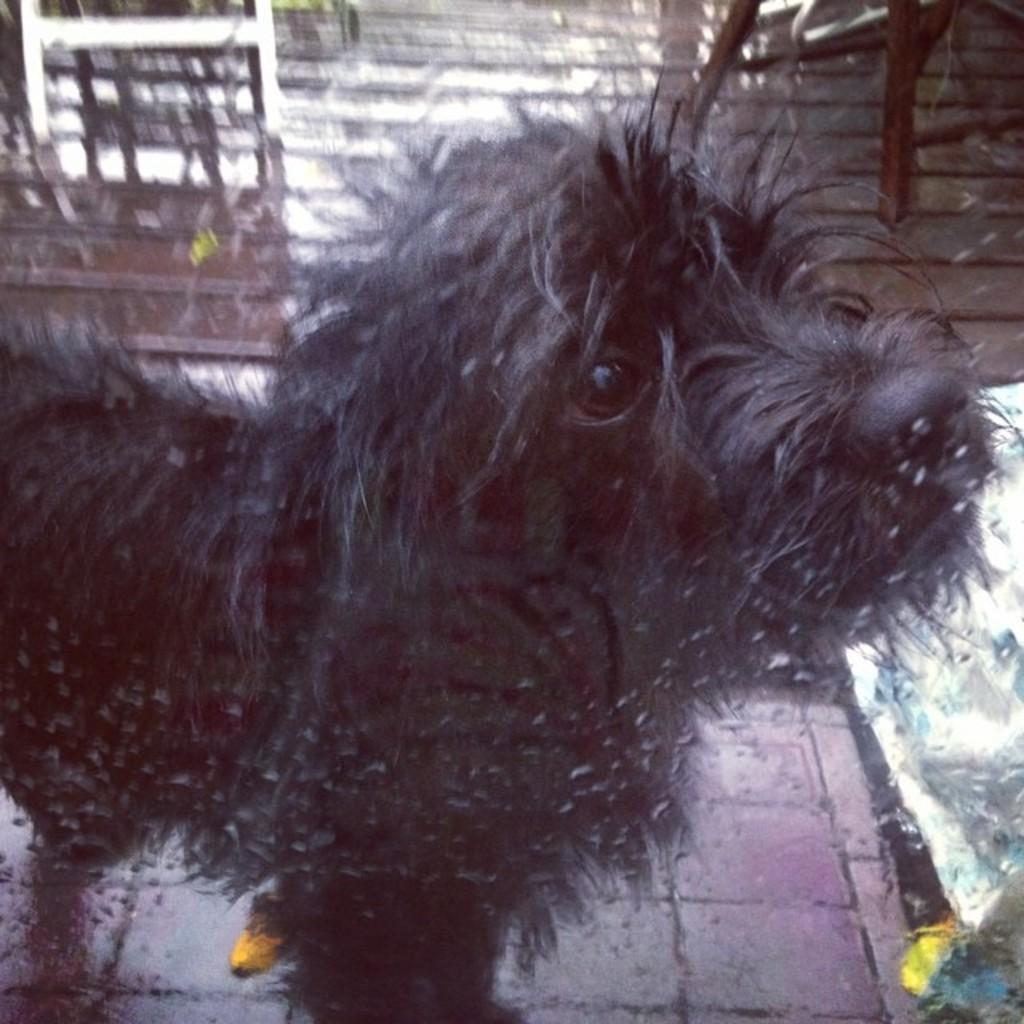What is the main subject of the image? There is a dog in the center of the image. Where is the dog located? The dog is on the floor. What can be seen in the background of the image? There is a wall in the background of the image. How many stars are visible in the image? There are no stars present in the image; it features a dog on the floor with a wall in the background. 